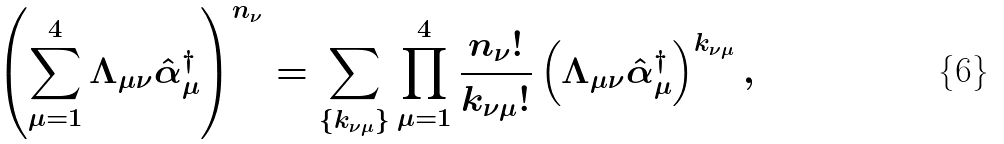<formula> <loc_0><loc_0><loc_500><loc_500>\left ( \sum _ { \mu = 1 } ^ { 4 } \Lambda _ { \mu \nu } \hat { \alpha } _ { \mu } ^ { \dagger } \right ) ^ { n _ { \nu } } = \sum _ { \{ k _ { \nu \mu } \} } \prod _ { \mu = 1 } ^ { 4 } \frac { n _ { \nu } ! } { k _ { \nu \mu } ! } \left ( \Lambda _ { \mu \nu } \hat { \alpha } _ { \mu } ^ { \dagger } \right ) ^ { k _ { \nu \mu } } ,</formula> 